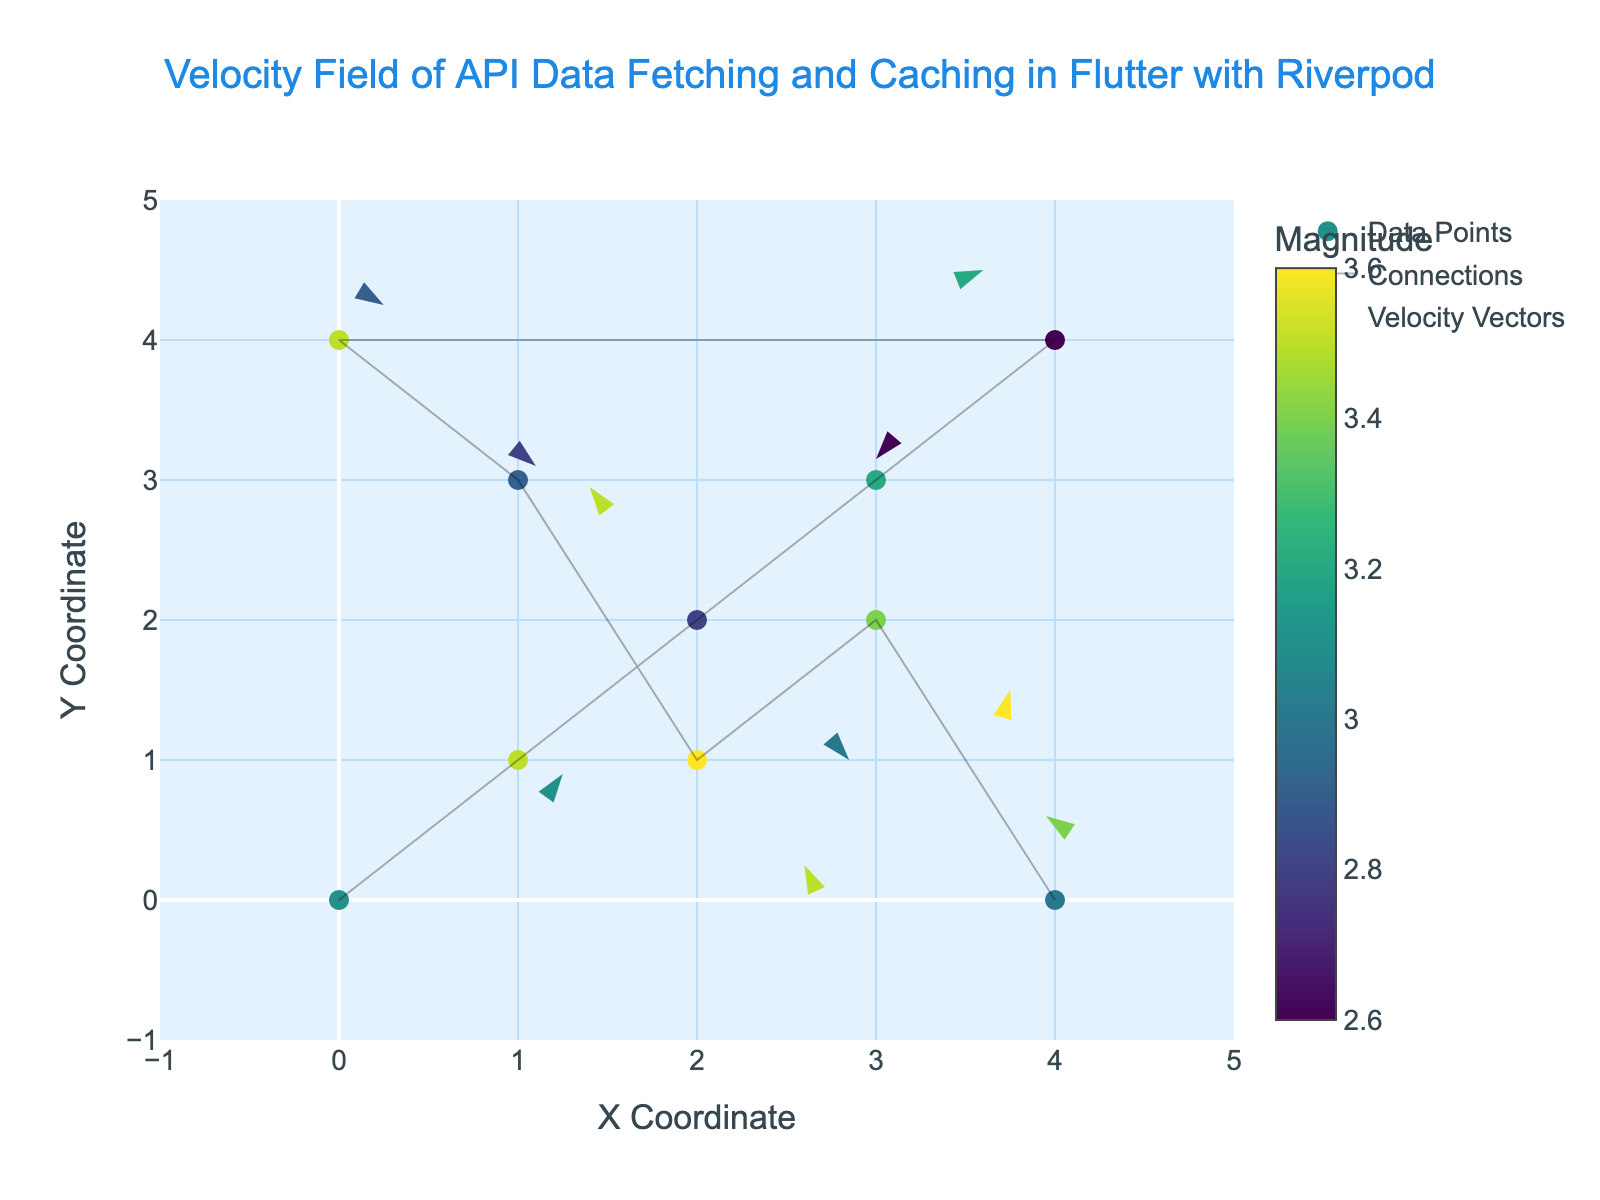what is the title of the plot? The title of the plot is displayed above the figure. It reads, "Velocity Field of API Data Fetching and Caching in Flutter with Riverpod". This can be seen in the top-center part of the figure.
Answer: Velocity Field of API Data Fetching and Caching in Flutter with Riverpod how many data points are shown in the plot? By looking at the markers in the plot, we can count the number of data points. Each marker represents a data point, and there are 10 such markers in the plot.
Answer: 10 what does the color of the markers represent? The color of the markers represents the magnitude. The color scale is shown on the right side of the plot with the title "Magnitude". Darker colors correspond to smaller magnitudes, and brighter colors correspond to larger magnitudes.
Answer: Magnitude which coordinate has the highest magnitude? By observing the color scale and the brightness of the markers, the coordinate at (1,1) seems to have the brightest marker, indicating the highest magnitude.
Answer: (1,1) what is the magnitude at coordinate (2,1)? We look at the color of the marker at coordinate (2,1) and refer to the color scale on the right. The color corresponds to a magnitude value, which is indicated by the graph. This magnitude is 3.6.
Answer: 3.6 which data point has a negative velocity in both x and y directions? Negative velocities are represented by vectors pointing towards negative values in both the x and y directions. By examining the arrows, we see that the point (4,4) has a velocity vector pointing down and to the left, indicating negative x and y velocities.
Answer: (4,4) how many data points have positive velocity in the x direction? Positive velocity in the x direction is denoted by arrows pointing to the right. By counting these arrows, we find there are 4 data points (0,0), (1,1), (2,1), and (3,3) with positive x direction velocity vectors.
Answer: 4 what is the average magnitude of the data points with positive x direction velocity? First, identify the points with positive x direction velocity: (0,0), (1,1), (2,1), and (3,3). Their magnitudes are 3.1, 3.5, 3.6, and 3.2 respectively. The average can be computed as (3.1 + 3.5 + 3.6 + 3.2) / 4 = 3.35.
Answer: 3.35 how does the magnitude at (2,2) compare to the magnitude at (4,0)? Observe the colors of the markers at (2,2) and (4,0) and refer to the color scale. The marker at (2,2) is less bright than the one at (4,0), indicating a smaller magnitude.
Answer: Smaller which data points have velocity vectors pointing towards the lower-left quadrant? Vectors pointing towards the lower-left quadrant have negative x and y velocities. By observing the arrows, the points (4,4) and (4,0) have such vectors.
Answer: (4,4) and (4,0) 